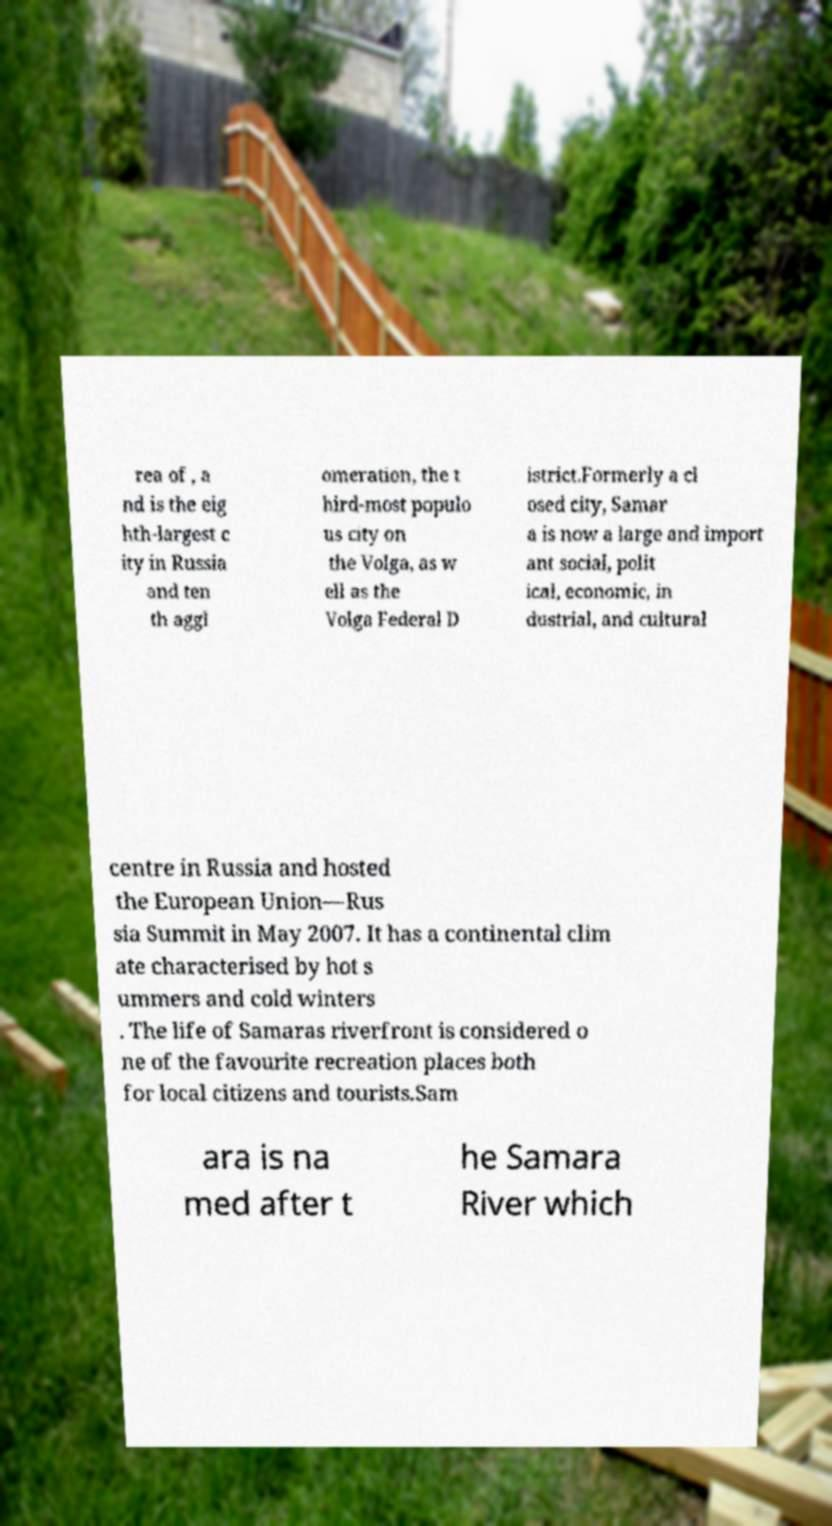There's text embedded in this image that I need extracted. Can you transcribe it verbatim? rea of , a nd is the eig hth-largest c ity in Russia and ten th aggl omeration, the t hird-most populo us city on the Volga, as w ell as the Volga Federal D istrict.Formerly a cl osed city, Samar a is now a large and import ant social, polit ical, economic, in dustrial, and cultural centre in Russia and hosted the European Union—Rus sia Summit in May 2007. It has a continental clim ate characterised by hot s ummers and cold winters . The life of Samaras riverfront is considered o ne of the favourite recreation places both for local citizens and tourists.Sam ara is na med after t he Samara River which 